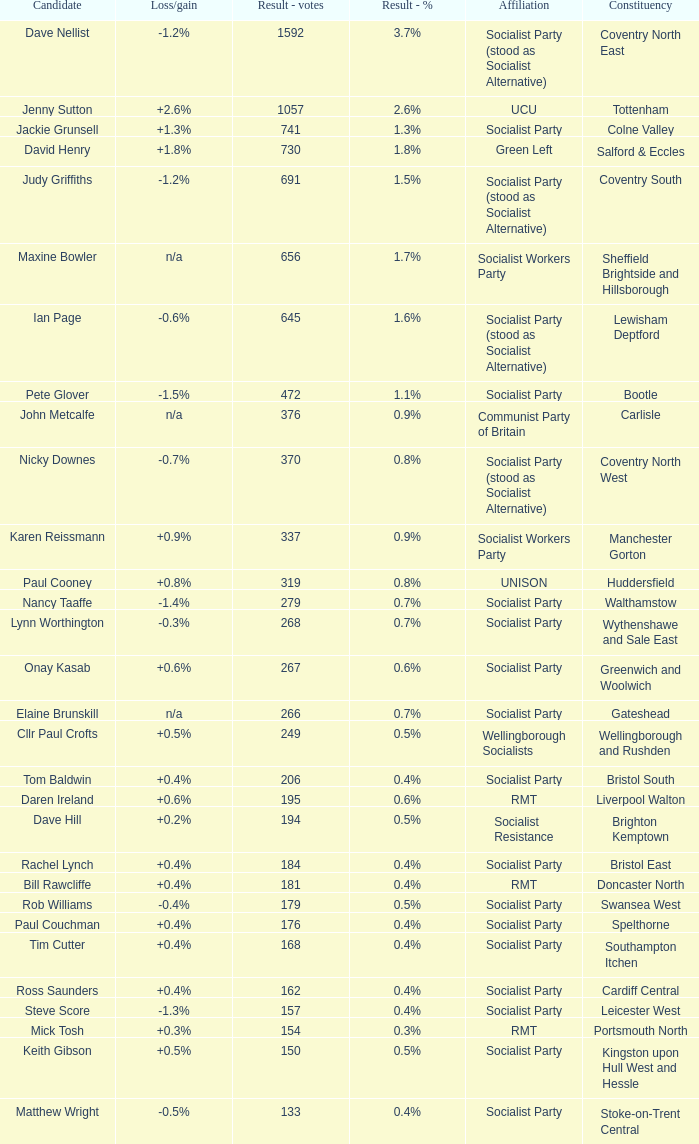What is the largest vote result for the Huddersfield constituency? 319.0. 